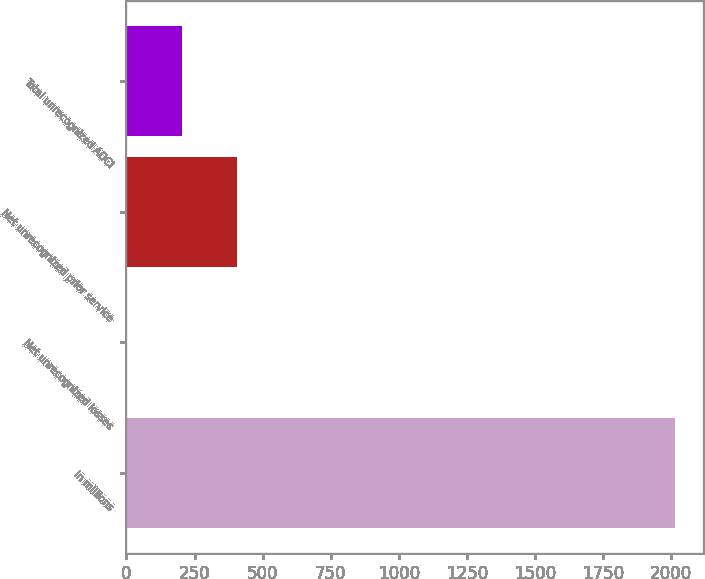Convert chart. <chart><loc_0><loc_0><loc_500><loc_500><bar_chart><fcel>in millions<fcel>Net unrecognized losses<fcel>Net unrecognized prior service<fcel>Total unrecognized AOCI<nl><fcel>2014<fcel>2<fcel>404.4<fcel>203.2<nl></chart> 